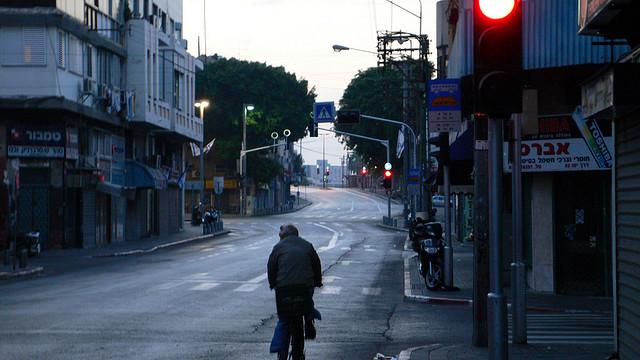How many people are using the road?
Keep it brief. 1. What color is the traffic light?
Quick response, please. Red. What vehicle is the man operating?
Keep it brief. Bicycle. Is this a busy street?
Answer briefly. No. What color is the light?
Quick response, please. Red. 